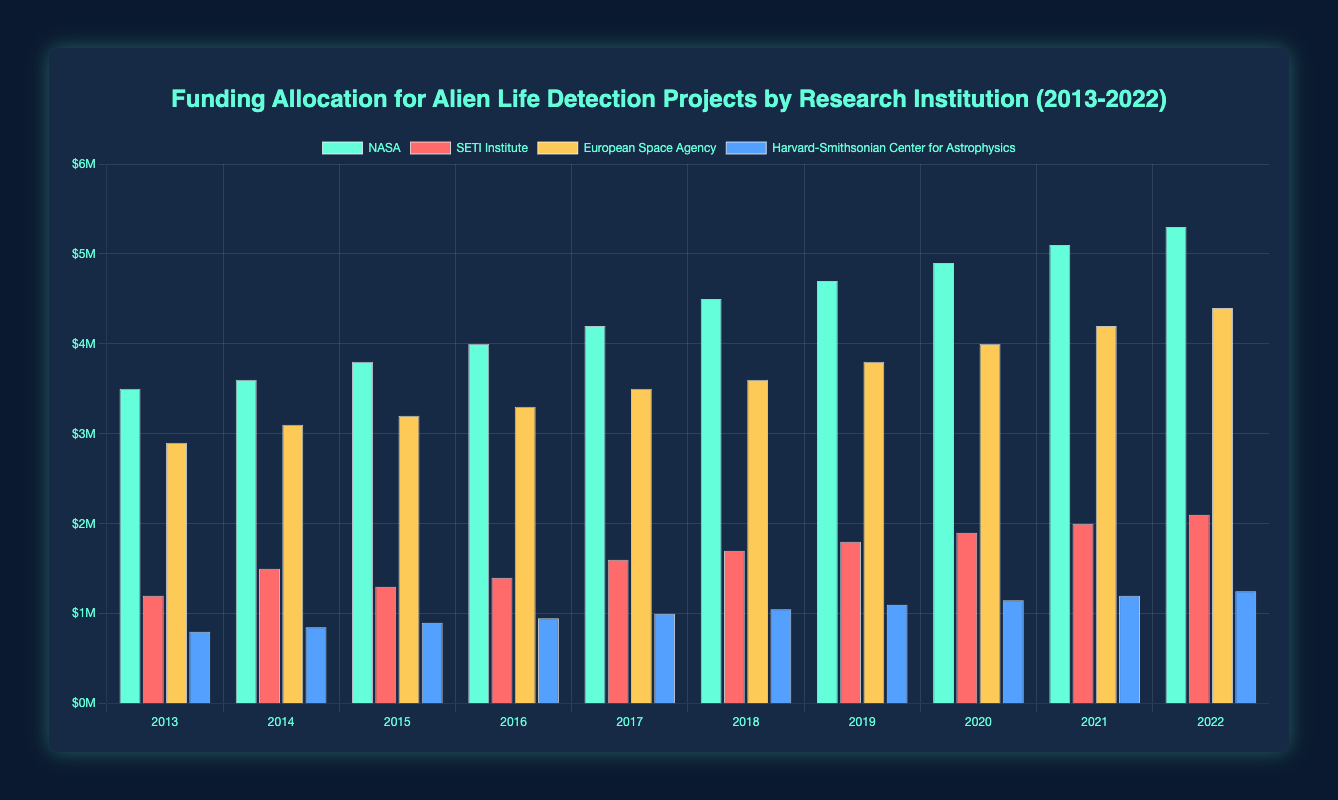Which institution received the highest funding in 2022? To determine the institution with the highest funding in 2022, locate the bars representing each institution for the year 2022. The tallest bar indicates the highest funding. NASA's bar is the tallest.
Answer: NASA How much more funding did NASA receive than the SETI Institute in 2020? Look at the bars for NASA and SETI Institute in 2020. NASA received $4.9M, and SETI Institute received $1.9M. Subtract the SETI Institute's funding from NASA's funding: $4.9M - $1.9M = $3M.
Answer: $3M Which year saw the largest increase in funding for the European Space Agency compared to the previous year? Compare the height of the bars for the European Space Agency year-over-year. The difference is largest from 2021 ($4.2M) to 2022 ($4.4M), making an increase of $0.2M.
Answer: 2022 Across the entire decade, what is the average annual funding received by Harvard-Smithsonian Center for Astrophysics? Sum the funding for Harvard-Smithsonian Center for Astrophysics across all years and divide by the number of years. ($0.8M + $0.85M + $0.90M + $0.95M + $1.0M + $1.05M + $1.1M + $1.15M + $1.2M + $1.25M) / 10 = $10M / 10 = $1M.
Answer: $1M How does the funding for the SETI Institute in 2015 compare to its funding in 2014? Compare the height of the bars for the SETI Institute in 2014 ($1.5M) and 2015 ($1.3M). The funding in 2015 is lower.
Answer: Lower Which institution has consistently increased its funding every year? Examine the trend in the height of bars for each institution. NASA's bars show a consistent year-over-year increase from 2013 to 2022.
Answer: NASA What is the total funding received by the European Space Agency over the last decade? Sum the funding amounts for the European Space Agency from 2013 to 2022. $2.9M + $3.1M + $3.2M + $3.3M + $3.5M + $3.6M + $3.8M + $4.0M + $4.2M + $4.4M = $36M.
Answer: $36M Between 2019 and 2022, which institution showed the largest absolute increase in funding? Calculate the absolute increase for each institution between 2019 and 2022. NASA: $5.3M - $4.7M = $0.6M, SETI Institute: $2.1M - $1.8M = $0.3M, European Space Agency: $4.4M - $3.8M = $0.6M, Harvard-Smithsonian Center for Astrophysics: $1.25M - $1.1M = $0.15M. NASA and the European Space Agency both increased by $0.6M.
Answer: NASA and European Space Agency 